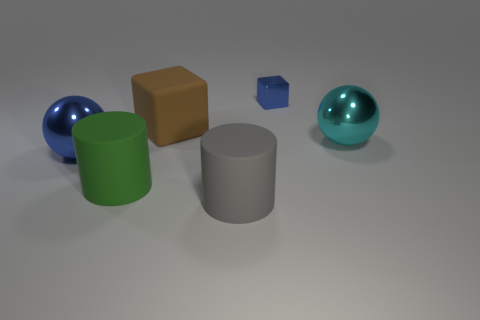Is there anything else that has the same size as the blue block?
Offer a terse response. No. There is a thing that is the same color as the shiny block; what is its size?
Your answer should be very brief. Large. Does the sphere that is to the left of the big cyan metallic thing have the same material as the brown thing that is behind the green matte cylinder?
Keep it short and to the point. No. What is the material of the other thing that is the same shape as the large green object?
Provide a short and direct response. Rubber. Is the big blue thing made of the same material as the gray cylinder?
Offer a terse response. No. There is a metal thing left of the metallic thing behind the cyan sphere; what is its color?
Offer a very short reply. Blue. There is another blue thing that is made of the same material as the small object; what is its size?
Your answer should be compact. Large. What number of large green matte things have the same shape as the tiny shiny object?
Keep it short and to the point. 0. What number of things are balls in front of the big cyan metal ball or big cylinders that are to the right of the rubber cube?
Ensure brevity in your answer.  2. There is a large metallic object that is left of the large green rubber cylinder; what number of big metal things are on the right side of it?
Provide a succinct answer. 1. 